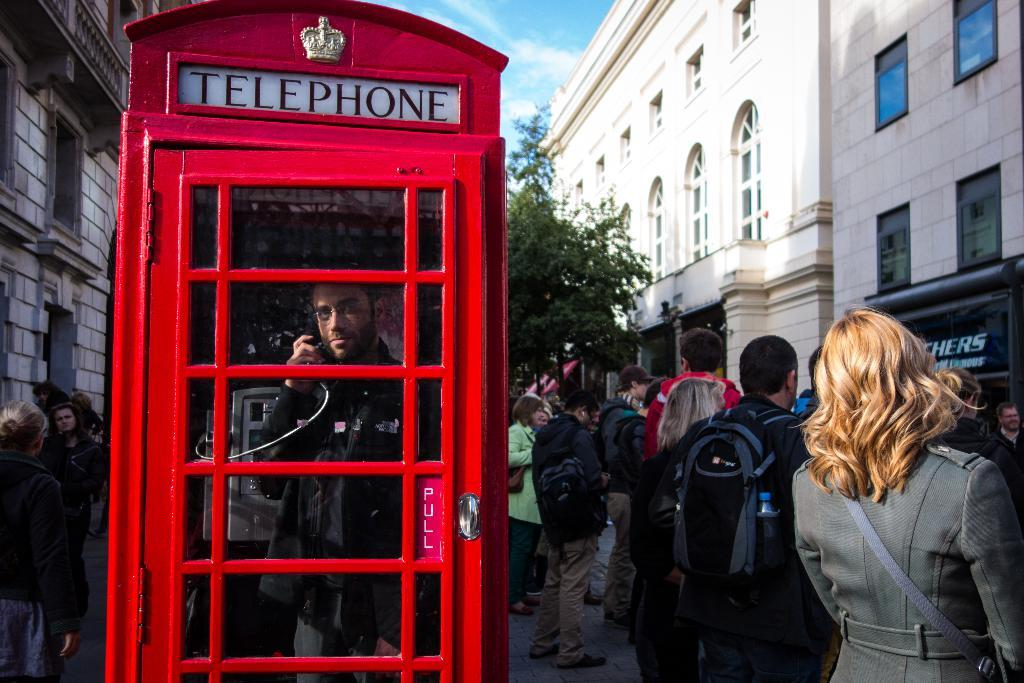<image>
Render a clear and concise summary of the photo. A crowded street scene with a red telephone booth. 